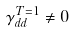<formula> <loc_0><loc_0><loc_500><loc_500>\gamma ^ { T = 1 } _ { d d } \neq 0</formula> 